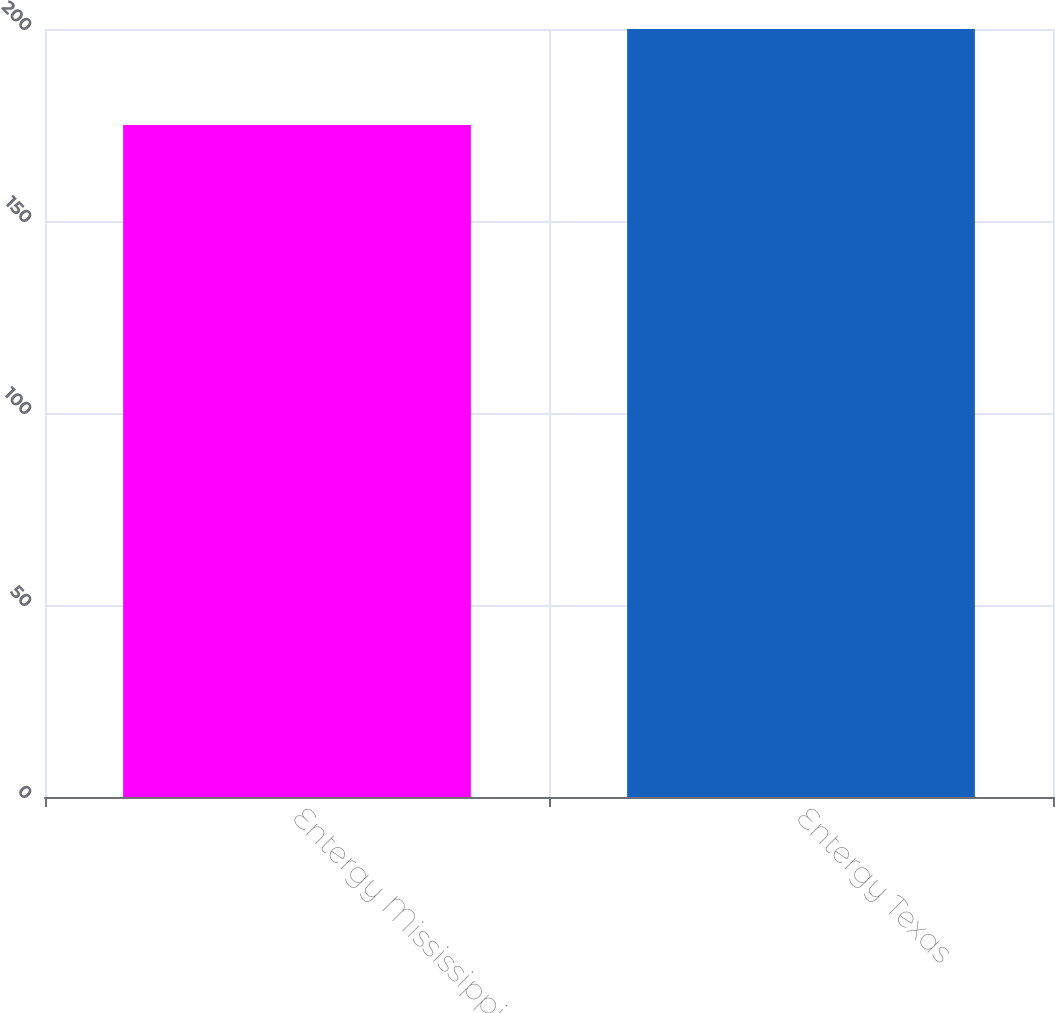Convert chart. <chart><loc_0><loc_0><loc_500><loc_500><bar_chart><fcel>Entergy Mississippi<fcel>Entergy Texas<nl><fcel>175<fcel>200<nl></chart> 